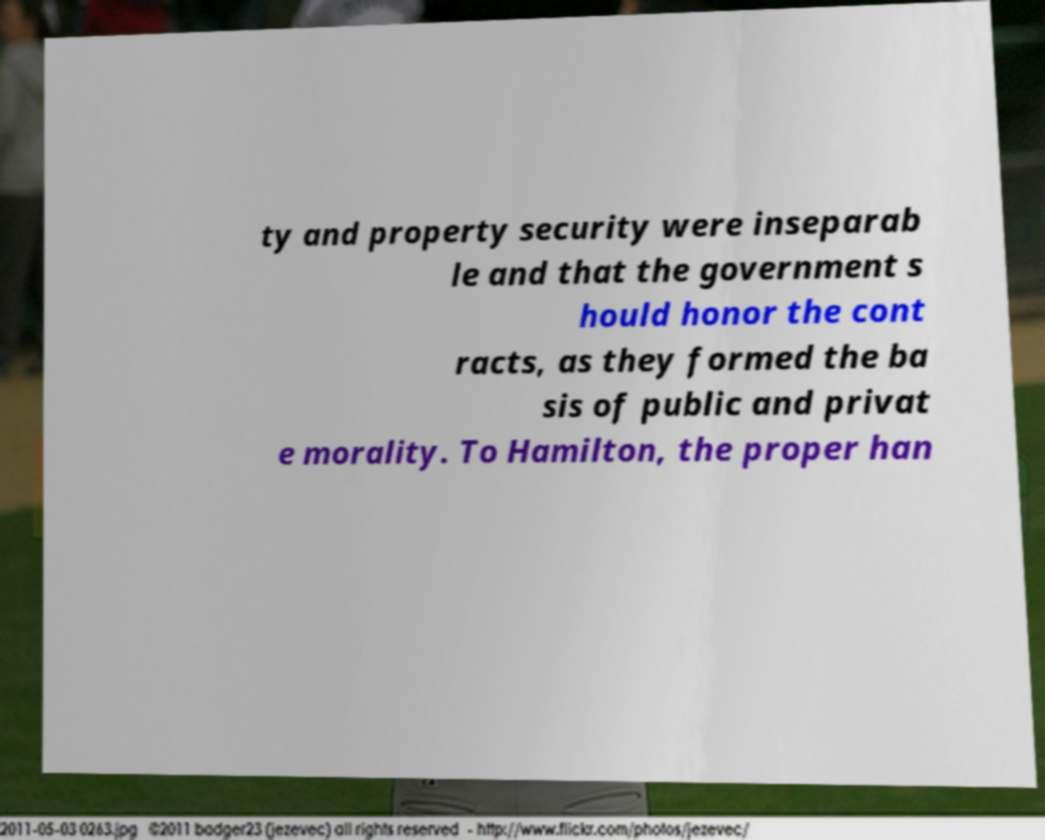Please read and relay the text visible in this image. What does it say? ty and property security were inseparab le and that the government s hould honor the cont racts, as they formed the ba sis of public and privat e morality. To Hamilton, the proper han 